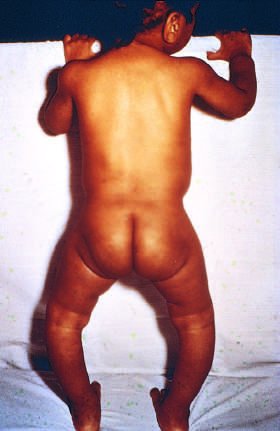s bowing of legs a consequence of the formation of poorly mineralized bone in a child with rickets?
Answer the question using a single word or phrase. Yes 